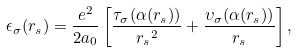Convert formula to latex. <formula><loc_0><loc_0><loc_500><loc_500>\epsilon _ { \sigma } ( r _ { s } ) = \frac { e ^ { 2 } } { 2 a _ { 0 } } \left [ \frac { \tau _ { \sigma } ( \alpha ( r _ { s } ) ) } { { r _ { s } } ^ { 2 } } + \frac { \upsilon _ { \sigma } ( \alpha ( r _ { s } ) ) } { r _ { s } } \right ] ,</formula> 